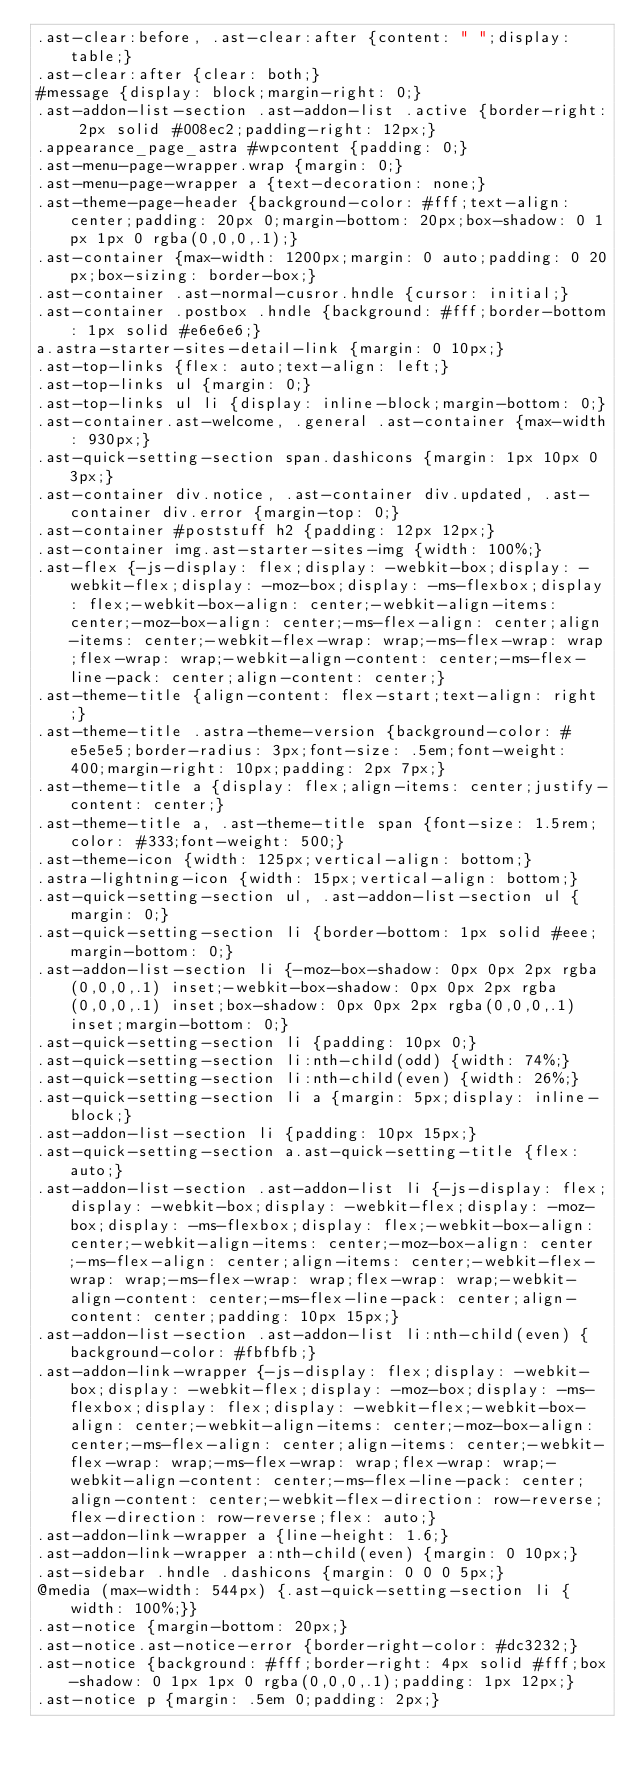Convert code to text. <code><loc_0><loc_0><loc_500><loc_500><_CSS_>.ast-clear:before, .ast-clear:after {content: " ";display: table;}
.ast-clear:after {clear: both;}
#message {display: block;margin-right: 0;}
.ast-addon-list-section .ast-addon-list .active {border-right: 2px solid #008ec2;padding-right: 12px;}
.appearance_page_astra #wpcontent {padding: 0;}
.ast-menu-page-wrapper.wrap {margin: 0;}
.ast-menu-page-wrapper a {text-decoration: none;}
.ast-theme-page-header {background-color: #fff;text-align: center;padding: 20px 0;margin-bottom: 20px;box-shadow: 0 1px 1px 0 rgba(0,0,0,.1);}
.ast-container {max-width: 1200px;margin: 0 auto;padding: 0 20px;box-sizing: border-box;}
.ast-container .ast-normal-cusror.hndle {cursor: initial;}
.ast-container .postbox .hndle {background: #fff;border-bottom: 1px solid #e6e6e6;}
a.astra-starter-sites-detail-link {margin: 0 10px;}
.ast-top-links {flex: auto;text-align: left;}
.ast-top-links ul {margin: 0;}
.ast-top-links ul li {display: inline-block;margin-bottom: 0;}
.ast-container.ast-welcome, .general .ast-container {max-width: 930px;}
.ast-quick-setting-section span.dashicons {margin: 1px 10px 0 3px;}
.ast-container div.notice, .ast-container div.updated, .ast-container div.error {margin-top: 0;}
.ast-container #poststuff h2 {padding: 12px 12px;}
.ast-container img.ast-starter-sites-img {width: 100%;}
.ast-flex {-js-display: flex;display: -webkit-box;display: -webkit-flex;display: -moz-box;display: -ms-flexbox;display: flex;-webkit-box-align: center;-webkit-align-items: center;-moz-box-align: center;-ms-flex-align: center;align-items: center;-webkit-flex-wrap: wrap;-ms-flex-wrap: wrap;flex-wrap: wrap;-webkit-align-content: center;-ms-flex-line-pack: center;align-content: center;}
.ast-theme-title {align-content: flex-start;text-align: right;}
.ast-theme-title .astra-theme-version {background-color: #e5e5e5;border-radius: 3px;font-size: .5em;font-weight: 400;margin-right: 10px;padding: 2px 7px;}
.ast-theme-title a {display: flex;align-items: center;justify-content: center;}
.ast-theme-title a, .ast-theme-title span {font-size: 1.5rem;color: #333;font-weight: 500;}
.ast-theme-icon {width: 125px;vertical-align: bottom;}
.astra-lightning-icon {width: 15px;vertical-align: bottom;}
.ast-quick-setting-section ul, .ast-addon-list-section ul {margin: 0;}
.ast-quick-setting-section li {border-bottom: 1px solid #eee;margin-bottom: 0;}
.ast-addon-list-section li {-moz-box-shadow: 0px 0px 2px rgba(0,0,0,.1) inset;-webkit-box-shadow: 0px 0px 2px rgba(0,0,0,.1) inset;box-shadow: 0px 0px 2px rgba(0,0,0,.1) inset;margin-bottom: 0;}
.ast-quick-setting-section li {padding: 10px 0;}
.ast-quick-setting-section li:nth-child(odd) {width: 74%;}
.ast-quick-setting-section li:nth-child(even) {width: 26%;}
.ast-quick-setting-section li a {margin: 5px;display: inline-block;}
.ast-addon-list-section li {padding: 10px 15px;}
.ast-quick-setting-section a.ast-quick-setting-title {flex: auto;}
.ast-addon-list-section .ast-addon-list li {-js-display: flex;display: -webkit-box;display: -webkit-flex;display: -moz-box;display: -ms-flexbox;display: flex;-webkit-box-align: center;-webkit-align-items: center;-moz-box-align: center;-ms-flex-align: center;align-items: center;-webkit-flex-wrap: wrap;-ms-flex-wrap: wrap;flex-wrap: wrap;-webkit-align-content: center;-ms-flex-line-pack: center;align-content: center;padding: 10px 15px;}
.ast-addon-list-section .ast-addon-list li:nth-child(even) {background-color: #fbfbfb;}
.ast-addon-link-wrapper {-js-display: flex;display: -webkit-box;display: -webkit-flex;display: -moz-box;display: -ms-flexbox;display: flex;display: -webkit-flex;-webkit-box-align: center;-webkit-align-items: center;-moz-box-align: center;-ms-flex-align: center;align-items: center;-webkit-flex-wrap: wrap;-ms-flex-wrap: wrap;flex-wrap: wrap;-webkit-align-content: center;-ms-flex-line-pack: center;align-content: center;-webkit-flex-direction: row-reverse;flex-direction: row-reverse;flex: auto;}
.ast-addon-link-wrapper a {line-height: 1.6;}
.ast-addon-link-wrapper a:nth-child(even) {margin: 0 10px;}
.ast-sidebar .hndle .dashicons {margin: 0 0 0 5px;}
@media (max-width: 544px) {.ast-quick-setting-section li {width: 100%;}}
.ast-notice {margin-bottom: 20px;}
.ast-notice.ast-notice-error {border-right-color: #dc3232;}
.ast-notice {background: #fff;border-right: 4px solid #fff;box-shadow: 0 1px 1px 0 rgba(0,0,0,.1);padding: 1px 12px;}
.ast-notice p {margin: .5em 0;padding: 2px;}</code> 